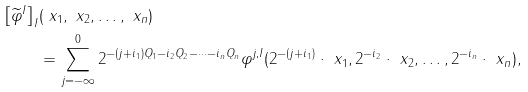<formula> <loc_0><loc_0><loc_500><loc_500>\left [ \widetilde { \varphi } ^ { I } \right ] _ { I } & ( \ x _ { 1 } , \ x _ { 2 } , \dots , \ x _ { n } ) \\ & = \sum _ { j = - \infty } ^ { 0 } 2 ^ { - ( j + i _ { 1 } ) Q _ { 1 } - i _ { 2 } Q _ { 2 } - \cdots - i _ { n } Q _ { n } } \varphi ^ { j , I } ( 2 ^ { - ( j + i _ { 1 } ) } \cdot \ x _ { 1 } , 2 ^ { - i _ { 2 } } \cdot \ x _ { 2 } , \dots , 2 ^ { - i _ { n } } \cdot \ x _ { n } ) ,</formula> 